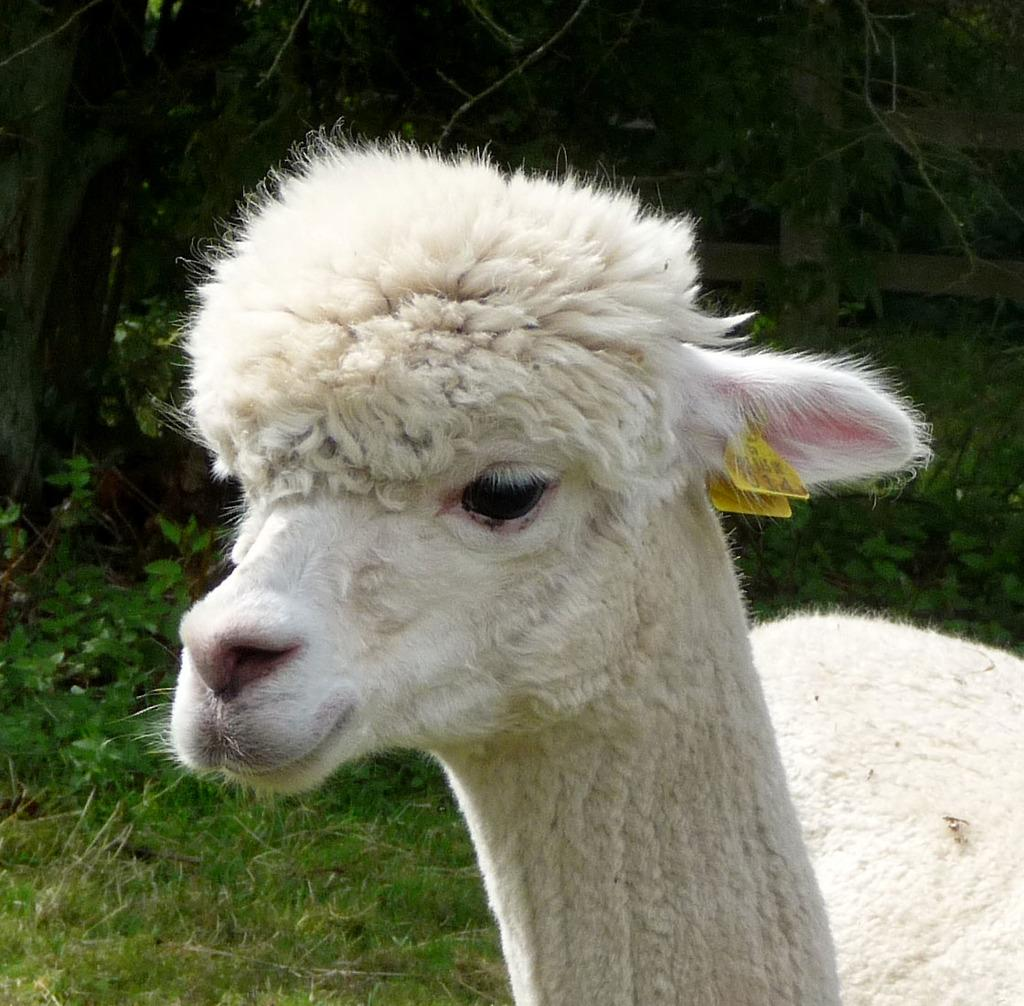What is the main subject in the center of the picture? There is an animal in the center of the picture. What can be seen in the background of the image? There are trees in the background of the image. What type of vegetation is at the bottom of the image? There is grass at the bottom of the image. What is the chance of finding a donkey in the mine in the image? There is no mine present in the image, and therefore no chance of finding a donkey in it. 